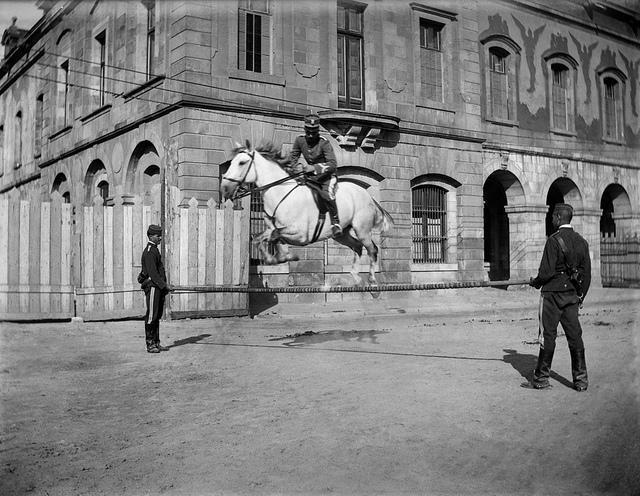How many people are in this picture?
Give a very brief answer. 3. How many people are there?
Give a very brief answer. 3. How many hands does the gold-rimmed clock have?
Give a very brief answer. 0. 